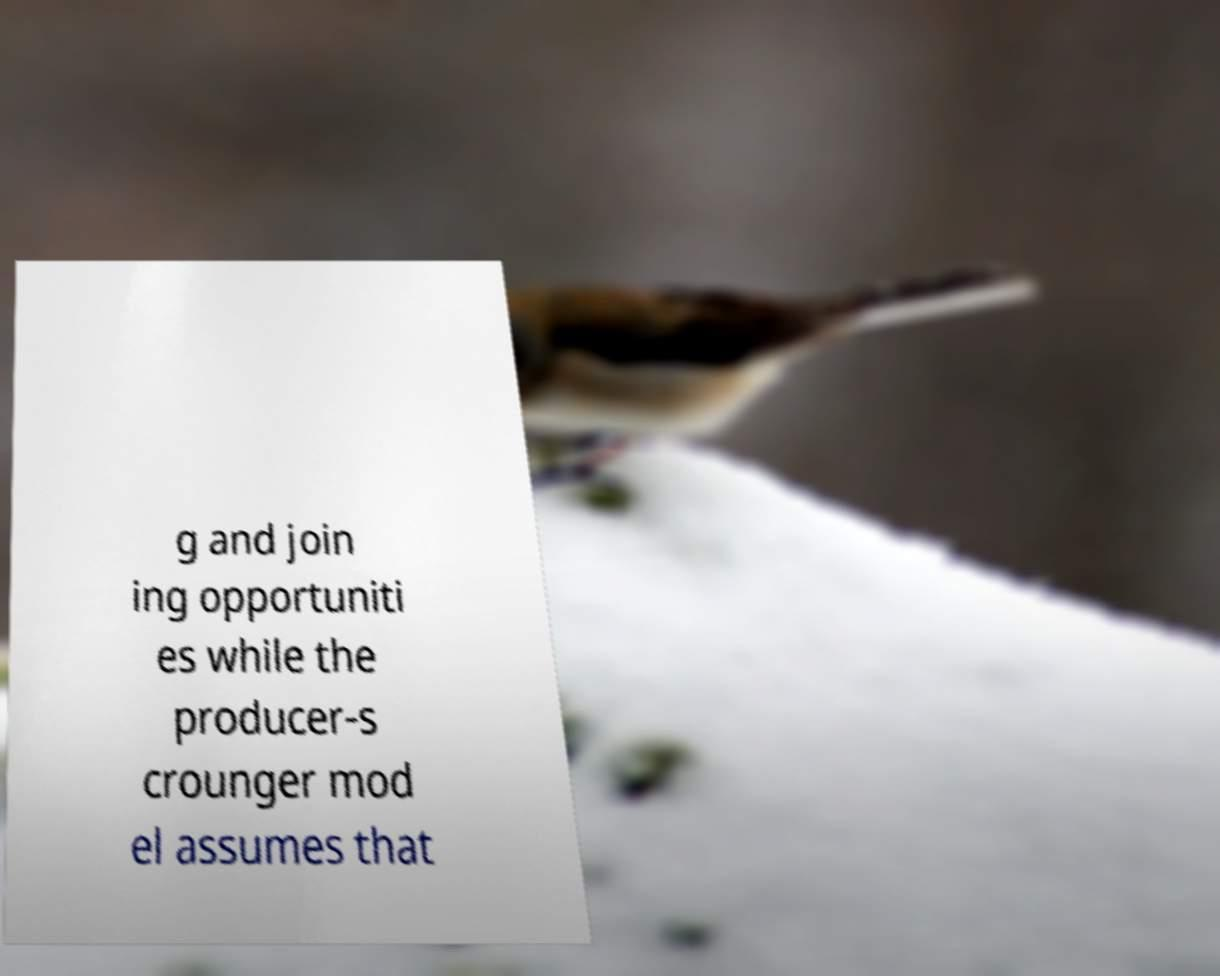Could you extract and type out the text from this image? g and join ing opportuniti es while the producer-s crounger mod el assumes that 